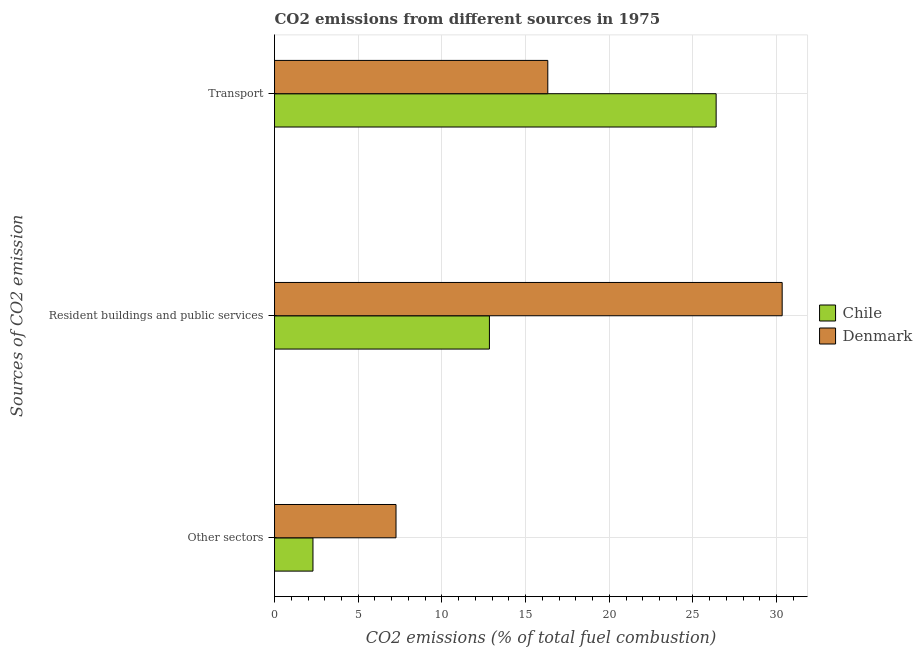How many groups of bars are there?
Keep it short and to the point. 3. Are the number of bars per tick equal to the number of legend labels?
Make the answer very short. Yes. What is the label of the 1st group of bars from the top?
Your answer should be compact. Transport. What is the percentage of co2 emissions from resident buildings and public services in Denmark?
Provide a short and direct response. 30.33. Across all countries, what is the maximum percentage of co2 emissions from transport?
Give a very brief answer. 26.38. Across all countries, what is the minimum percentage of co2 emissions from other sectors?
Provide a succinct answer. 2.3. What is the total percentage of co2 emissions from resident buildings and public services in the graph?
Provide a succinct answer. 43.17. What is the difference between the percentage of co2 emissions from resident buildings and public services in Chile and that in Denmark?
Offer a very short reply. -17.49. What is the difference between the percentage of co2 emissions from resident buildings and public services in Denmark and the percentage of co2 emissions from other sectors in Chile?
Give a very brief answer. 28.03. What is the average percentage of co2 emissions from other sectors per country?
Provide a succinct answer. 4.78. What is the difference between the percentage of co2 emissions from other sectors and percentage of co2 emissions from resident buildings and public services in Denmark?
Offer a very short reply. -23.07. What is the ratio of the percentage of co2 emissions from resident buildings and public services in Denmark to that in Chile?
Your answer should be very brief. 2.36. Is the percentage of co2 emissions from other sectors in Denmark less than that in Chile?
Your answer should be compact. No. Is the difference between the percentage of co2 emissions from other sectors in Denmark and Chile greater than the difference between the percentage of co2 emissions from transport in Denmark and Chile?
Make the answer very short. Yes. What is the difference between the highest and the second highest percentage of co2 emissions from resident buildings and public services?
Offer a terse response. 17.49. What is the difference between the highest and the lowest percentage of co2 emissions from other sectors?
Offer a very short reply. 4.96. In how many countries, is the percentage of co2 emissions from other sectors greater than the average percentage of co2 emissions from other sectors taken over all countries?
Provide a short and direct response. 1. Is the sum of the percentage of co2 emissions from other sectors in Chile and Denmark greater than the maximum percentage of co2 emissions from resident buildings and public services across all countries?
Give a very brief answer. No. What does the 2nd bar from the top in Resident buildings and public services represents?
Keep it short and to the point. Chile. What does the 1st bar from the bottom in Other sectors represents?
Offer a very short reply. Chile. How many bars are there?
Ensure brevity in your answer.  6. Are the values on the major ticks of X-axis written in scientific E-notation?
Offer a terse response. No. Does the graph contain any zero values?
Your response must be concise. No. Where does the legend appear in the graph?
Provide a short and direct response. Center right. What is the title of the graph?
Provide a short and direct response. CO2 emissions from different sources in 1975. Does "New Caledonia" appear as one of the legend labels in the graph?
Your answer should be compact. No. What is the label or title of the X-axis?
Ensure brevity in your answer.  CO2 emissions (% of total fuel combustion). What is the label or title of the Y-axis?
Make the answer very short. Sources of CO2 emission. What is the CO2 emissions (% of total fuel combustion) in Chile in Other sectors?
Provide a short and direct response. 2.3. What is the CO2 emissions (% of total fuel combustion) of Denmark in Other sectors?
Provide a short and direct response. 7.26. What is the CO2 emissions (% of total fuel combustion) in Chile in Resident buildings and public services?
Your answer should be compact. 12.84. What is the CO2 emissions (% of total fuel combustion) in Denmark in Resident buildings and public services?
Offer a very short reply. 30.33. What is the CO2 emissions (% of total fuel combustion) in Chile in Transport?
Your response must be concise. 26.38. What is the CO2 emissions (% of total fuel combustion) of Denmark in Transport?
Offer a terse response. 16.33. Across all Sources of CO2 emission, what is the maximum CO2 emissions (% of total fuel combustion) in Chile?
Your answer should be very brief. 26.38. Across all Sources of CO2 emission, what is the maximum CO2 emissions (% of total fuel combustion) in Denmark?
Offer a very short reply. 30.33. Across all Sources of CO2 emission, what is the minimum CO2 emissions (% of total fuel combustion) of Chile?
Offer a terse response. 2.3. Across all Sources of CO2 emission, what is the minimum CO2 emissions (% of total fuel combustion) of Denmark?
Your response must be concise. 7.26. What is the total CO2 emissions (% of total fuel combustion) in Chile in the graph?
Ensure brevity in your answer.  41.52. What is the total CO2 emissions (% of total fuel combustion) of Denmark in the graph?
Offer a very short reply. 53.91. What is the difference between the CO2 emissions (% of total fuel combustion) of Chile in Other sectors and that in Resident buildings and public services?
Your answer should be compact. -10.54. What is the difference between the CO2 emissions (% of total fuel combustion) in Denmark in Other sectors and that in Resident buildings and public services?
Your answer should be very brief. -23.07. What is the difference between the CO2 emissions (% of total fuel combustion) in Chile in Other sectors and that in Transport?
Give a very brief answer. -24.09. What is the difference between the CO2 emissions (% of total fuel combustion) of Denmark in Other sectors and that in Transport?
Make the answer very short. -9.07. What is the difference between the CO2 emissions (% of total fuel combustion) in Chile in Resident buildings and public services and that in Transport?
Your response must be concise. -13.55. What is the difference between the CO2 emissions (% of total fuel combustion) of Denmark in Resident buildings and public services and that in Transport?
Make the answer very short. 14. What is the difference between the CO2 emissions (% of total fuel combustion) in Chile in Other sectors and the CO2 emissions (% of total fuel combustion) in Denmark in Resident buildings and public services?
Your answer should be very brief. -28.03. What is the difference between the CO2 emissions (% of total fuel combustion) in Chile in Other sectors and the CO2 emissions (% of total fuel combustion) in Denmark in Transport?
Ensure brevity in your answer.  -14.03. What is the difference between the CO2 emissions (% of total fuel combustion) of Chile in Resident buildings and public services and the CO2 emissions (% of total fuel combustion) of Denmark in Transport?
Offer a terse response. -3.49. What is the average CO2 emissions (% of total fuel combustion) in Chile per Sources of CO2 emission?
Offer a terse response. 13.84. What is the average CO2 emissions (% of total fuel combustion) in Denmark per Sources of CO2 emission?
Give a very brief answer. 17.97. What is the difference between the CO2 emissions (% of total fuel combustion) of Chile and CO2 emissions (% of total fuel combustion) of Denmark in Other sectors?
Offer a terse response. -4.96. What is the difference between the CO2 emissions (% of total fuel combustion) of Chile and CO2 emissions (% of total fuel combustion) of Denmark in Resident buildings and public services?
Offer a terse response. -17.49. What is the difference between the CO2 emissions (% of total fuel combustion) in Chile and CO2 emissions (% of total fuel combustion) in Denmark in Transport?
Keep it short and to the point. 10.06. What is the ratio of the CO2 emissions (% of total fuel combustion) of Chile in Other sectors to that in Resident buildings and public services?
Your answer should be very brief. 0.18. What is the ratio of the CO2 emissions (% of total fuel combustion) of Denmark in Other sectors to that in Resident buildings and public services?
Keep it short and to the point. 0.24. What is the ratio of the CO2 emissions (% of total fuel combustion) in Chile in Other sectors to that in Transport?
Keep it short and to the point. 0.09. What is the ratio of the CO2 emissions (% of total fuel combustion) in Denmark in Other sectors to that in Transport?
Make the answer very short. 0.44. What is the ratio of the CO2 emissions (% of total fuel combustion) of Chile in Resident buildings and public services to that in Transport?
Your response must be concise. 0.49. What is the ratio of the CO2 emissions (% of total fuel combustion) in Denmark in Resident buildings and public services to that in Transport?
Keep it short and to the point. 1.86. What is the difference between the highest and the second highest CO2 emissions (% of total fuel combustion) in Chile?
Keep it short and to the point. 13.55. What is the difference between the highest and the second highest CO2 emissions (% of total fuel combustion) in Denmark?
Your answer should be very brief. 14. What is the difference between the highest and the lowest CO2 emissions (% of total fuel combustion) in Chile?
Ensure brevity in your answer.  24.09. What is the difference between the highest and the lowest CO2 emissions (% of total fuel combustion) of Denmark?
Make the answer very short. 23.07. 